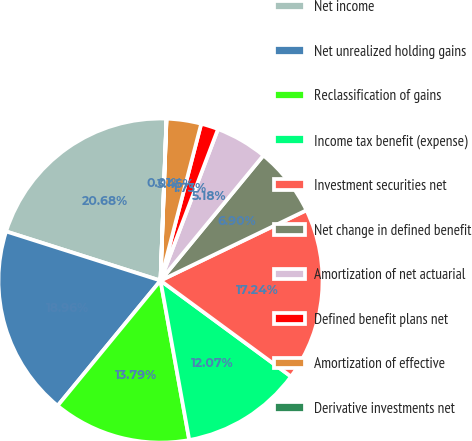Convert chart. <chart><loc_0><loc_0><loc_500><loc_500><pie_chart><fcel>Net income<fcel>Net unrealized holding gains<fcel>Reclassification of gains<fcel>Income tax benefit (expense)<fcel>Investment securities net<fcel>Net change in defined benefit<fcel>Amortization of net actuarial<fcel>Defined benefit plans net<fcel>Amortization of effective<fcel>Derivative investments net<nl><fcel>20.68%<fcel>18.96%<fcel>13.79%<fcel>12.07%<fcel>17.24%<fcel>6.9%<fcel>5.18%<fcel>1.73%<fcel>3.45%<fcel>0.01%<nl></chart> 